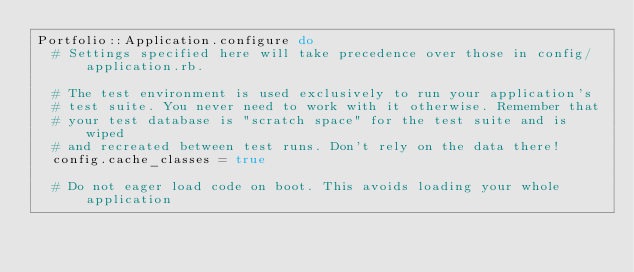<code> <loc_0><loc_0><loc_500><loc_500><_Ruby_>Portfolio::Application.configure do
  # Settings specified here will take precedence over those in config/application.rb.

  # The test environment is used exclusively to run your application's
  # test suite. You never need to work with it otherwise. Remember that
  # your test database is "scratch space" for the test suite and is wiped
  # and recreated between test runs. Don't rely on the data there!
  config.cache_classes = true

  # Do not eager load code on boot. This avoids loading your whole application</code> 